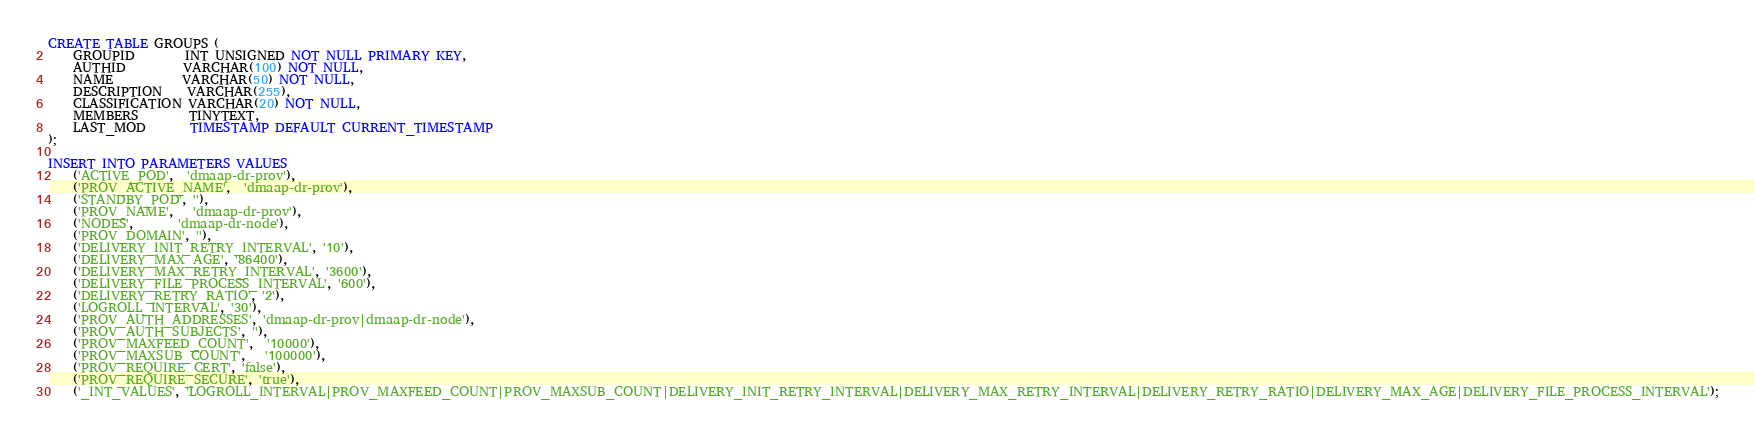Convert code to text. <code><loc_0><loc_0><loc_500><loc_500><_SQL_>
CREATE TABLE GROUPS (
    GROUPID        INT UNSIGNED NOT NULL PRIMARY KEY,
    AUTHID         VARCHAR(100) NOT NULL,
    NAME           VARCHAR(50) NOT NULL,
    DESCRIPTION    VARCHAR(255),
    CLASSIFICATION VARCHAR(20) NOT NULL,
    MEMBERS        TINYTEXT,
    LAST_MOD       TIMESTAMP DEFAULT CURRENT_TIMESTAMP
);

INSERT INTO PARAMETERS VALUES
    ('ACTIVE_POD',  'dmaap-dr-prov'),
    ('PROV_ACTIVE_NAME',  'dmaap-dr-prov'),
    ('STANDBY_POD', ''),
    ('PROV_NAME',   'dmaap-dr-prov'),
    ('NODES',       'dmaap-dr-node'),
    ('PROV_DOMAIN', ''),
    ('DELIVERY_INIT_RETRY_INTERVAL', '10'),
    ('DELIVERY_MAX_AGE', '86400'),
    ('DELIVERY_MAX_RETRY_INTERVAL', '3600'),
    ('DELIVERY_FILE_PROCESS_INTERVAL', '600'),
    ('DELIVERY_RETRY_RATIO', '2'),
    ('LOGROLL_INTERVAL', '30'),
    ('PROV_AUTH_ADDRESSES', 'dmaap-dr-prov|dmaap-dr-node'),
    ('PROV_AUTH_SUBJECTS', ''),
    ('PROV_MAXFEED_COUNT',  '10000'),
    ('PROV_MAXSUB_COUNT',   '100000'),
    ('PROV_REQUIRE_CERT', 'false'),
    ('PROV_REQUIRE_SECURE', 'true'),
    ('_INT_VALUES', 'LOGROLL_INTERVAL|PROV_MAXFEED_COUNT|PROV_MAXSUB_COUNT|DELIVERY_INIT_RETRY_INTERVAL|DELIVERY_MAX_RETRY_INTERVAL|DELIVERY_RETRY_RATIO|DELIVERY_MAX_AGE|DELIVERY_FILE_PROCESS_INTERVAL');</code> 